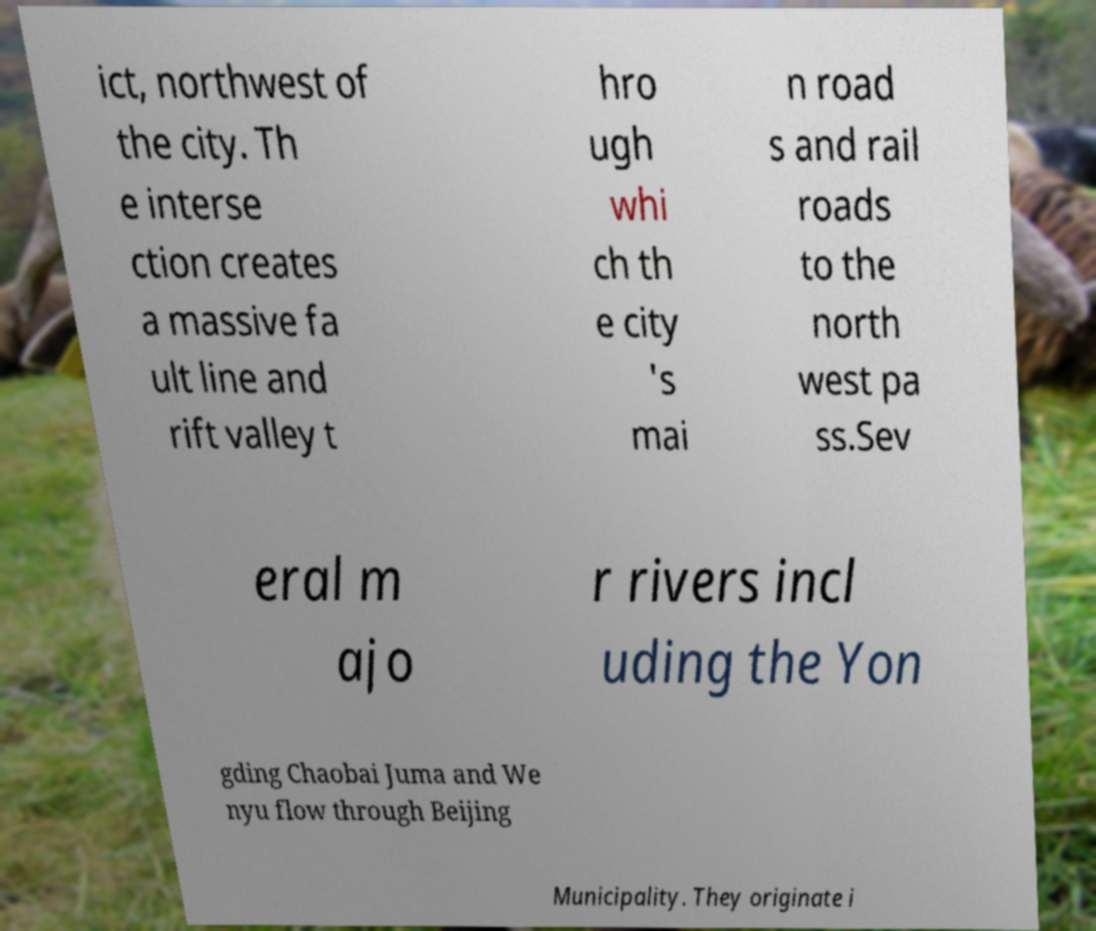What messages or text are displayed in this image? I need them in a readable, typed format. ict, northwest of the city. Th e interse ction creates a massive fa ult line and rift valley t hro ugh whi ch th e city 's mai n road s and rail roads to the north west pa ss.Sev eral m ajo r rivers incl uding the Yon gding Chaobai Juma and We nyu flow through Beijing Municipality. They originate i 